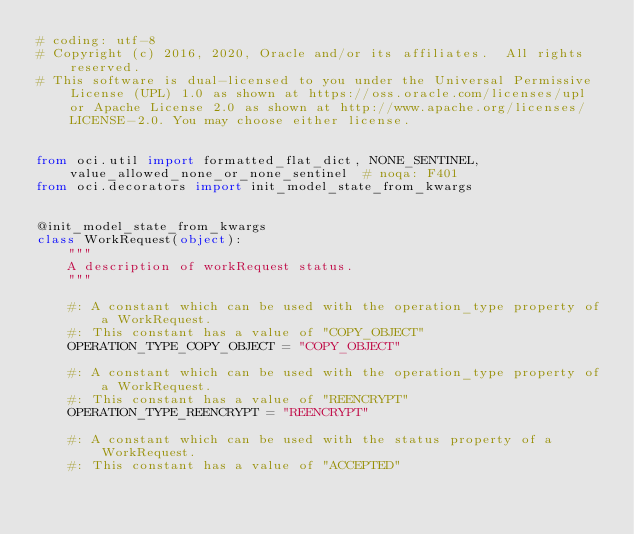Convert code to text. <code><loc_0><loc_0><loc_500><loc_500><_Python_># coding: utf-8
# Copyright (c) 2016, 2020, Oracle and/or its affiliates.  All rights reserved.
# This software is dual-licensed to you under the Universal Permissive License (UPL) 1.0 as shown at https://oss.oracle.com/licenses/upl or Apache License 2.0 as shown at http://www.apache.org/licenses/LICENSE-2.0. You may choose either license.


from oci.util import formatted_flat_dict, NONE_SENTINEL, value_allowed_none_or_none_sentinel  # noqa: F401
from oci.decorators import init_model_state_from_kwargs


@init_model_state_from_kwargs
class WorkRequest(object):
    """
    A description of workRequest status.
    """

    #: A constant which can be used with the operation_type property of a WorkRequest.
    #: This constant has a value of "COPY_OBJECT"
    OPERATION_TYPE_COPY_OBJECT = "COPY_OBJECT"

    #: A constant which can be used with the operation_type property of a WorkRequest.
    #: This constant has a value of "REENCRYPT"
    OPERATION_TYPE_REENCRYPT = "REENCRYPT"

    #: A constant which can be used with the status property of a WorkRequest.
    #: This constant has a value of "ACCEPTED"</code> 